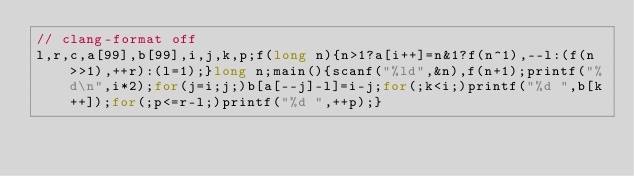Convert code to text. <code><loc_0><loc_0><loc_500><loc_500><_C_>// clang-format off
l,r,c,a[99],b[99],i,j,k,p;f(long n){n>1?a[i++]=n&1?f(n^1),--l:(f(n>>1),++r):(l=1);}long n;main(){scanf("%ld",&n),f(n+1);printf("%d\n",i*2);for(j=i;j;)b[a[--j]-l]=i-j;for(;k<i;)printf("%d ",b[k++]);for(;p<=r-l;)printf("%d ",++p);}</code> 